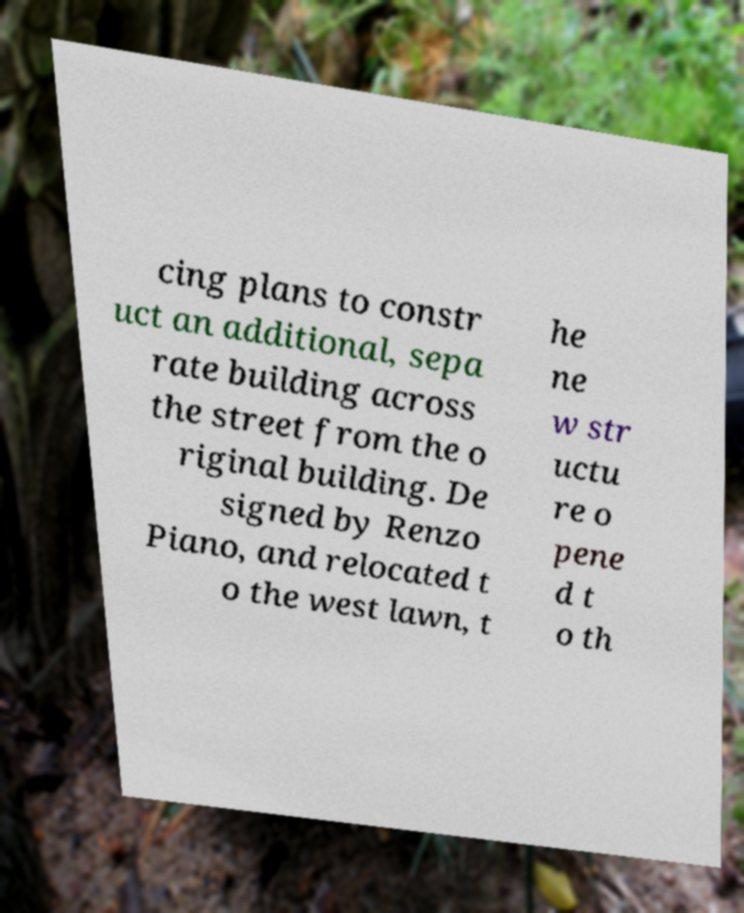Please read and relay the text visible in this image. What does it say? cing plans to constr uct an additional, sepa rate building across the street from the o riginal building. De signed by Renzo Piano, and relocated t o the west lawn, t he ne w str uctu re o pene d t o th 